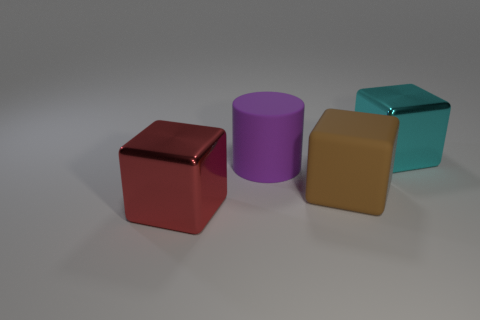Is the number of purple things that are to the right of the red object greater than the number of large purple cylinders in front of the brown object?
Your answer should be very brief. Yes. What is the cyan object made of?
Keep it short and to the point. Metal. There is a shiny thing in front of the metal thing that is right of the large cube that is to the left of the large brown rubber thing; what shape is it?
Your answer should be compact. Cube. What number of other objects are the same material as the large red object?
Offer a terse response. 1. Are the big object that is left of the large purple thing and the thing that is behind the big cylinder made of the same material?
Provide a succinct answer. Yes. What number of things are both behind the matte block and to the right of the large purple rubber cylinder?
Offer a very short reply. 1. Are there any cyan objects that have the same shape as the big brown thing?
Give a very brief answer. Yes. What shape is the brown matte object that is the same size as the purple rubber cylinder?
Your response must be concise. Cube. Is the number of large brown rubber things to the right of the cyan metallic block the same as the number of metal cubes behind the big purple rubber cylinder?
Ensure brevity in your answer.  No. Is there a purple metal thing that has the same size as the rubber cube?
Give a very brief answer. No. 